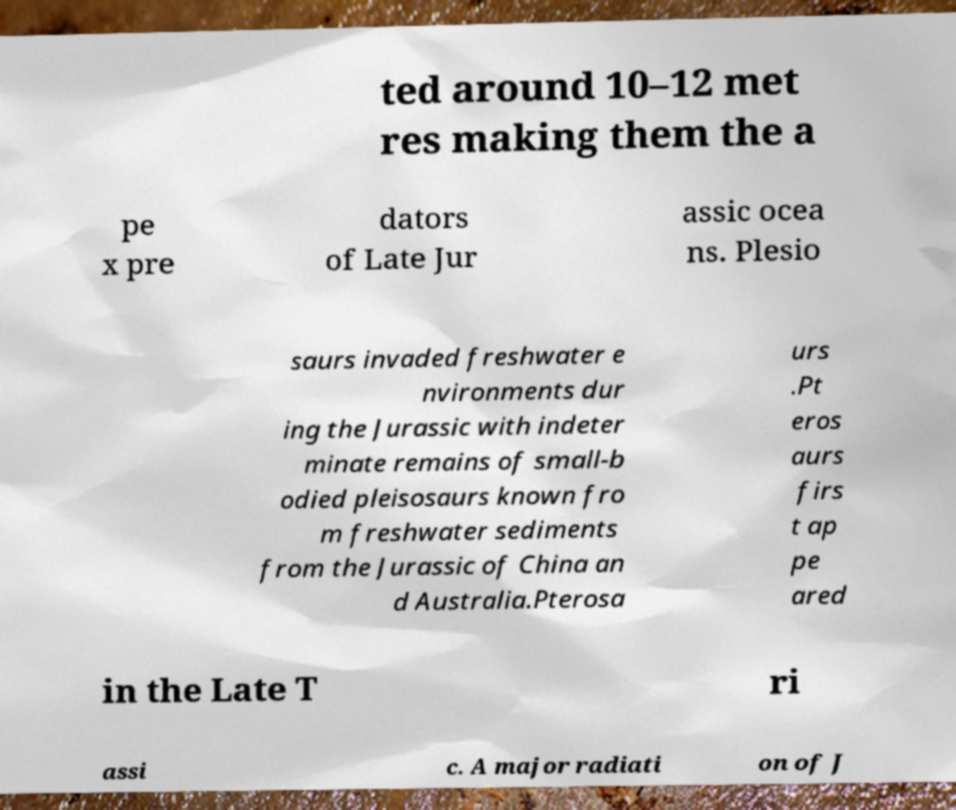Can you accurately transcribe the text from the provided image for me? ted around 10–12 met res making them the a pe x pre dators of Late Jur assic ocea ns. Plesio saurs invaded freshwater e nvironments dur ing the Jurassic with indeter minate remains of small-b odied pleisosaurs known fro m freshwater sediments from the Jurassic of China an d Australia.Pterosa urs .Pt eros aurs firs t ap pe ared in the Late T ri assi c. A major radiati on of J 